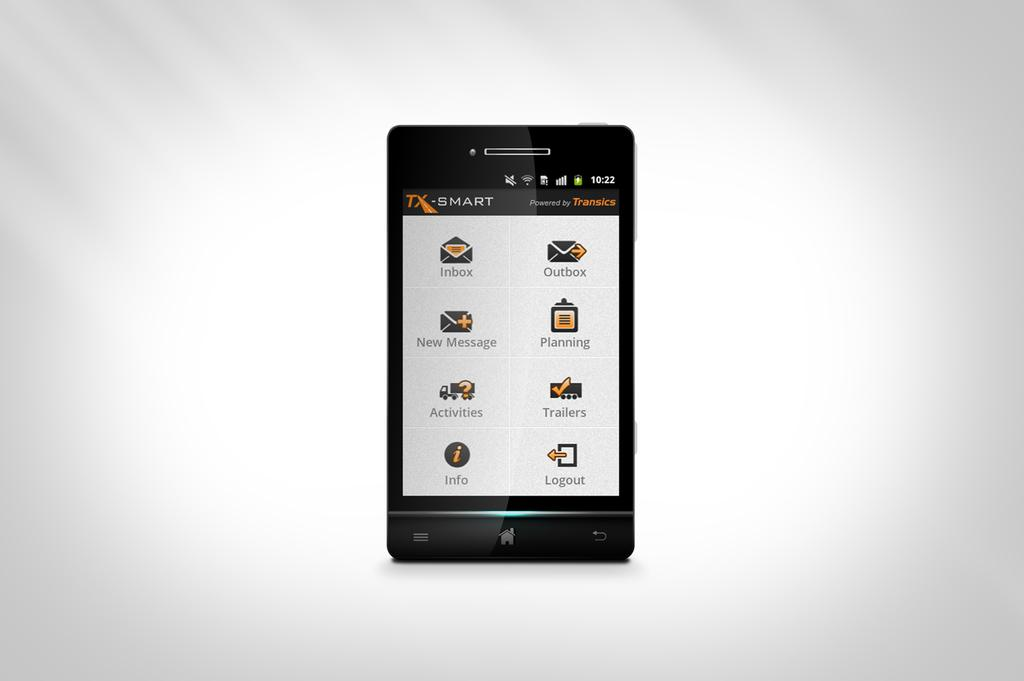<image>
Provide a brief description of the given image. The black and white phone is powered by Transics. 